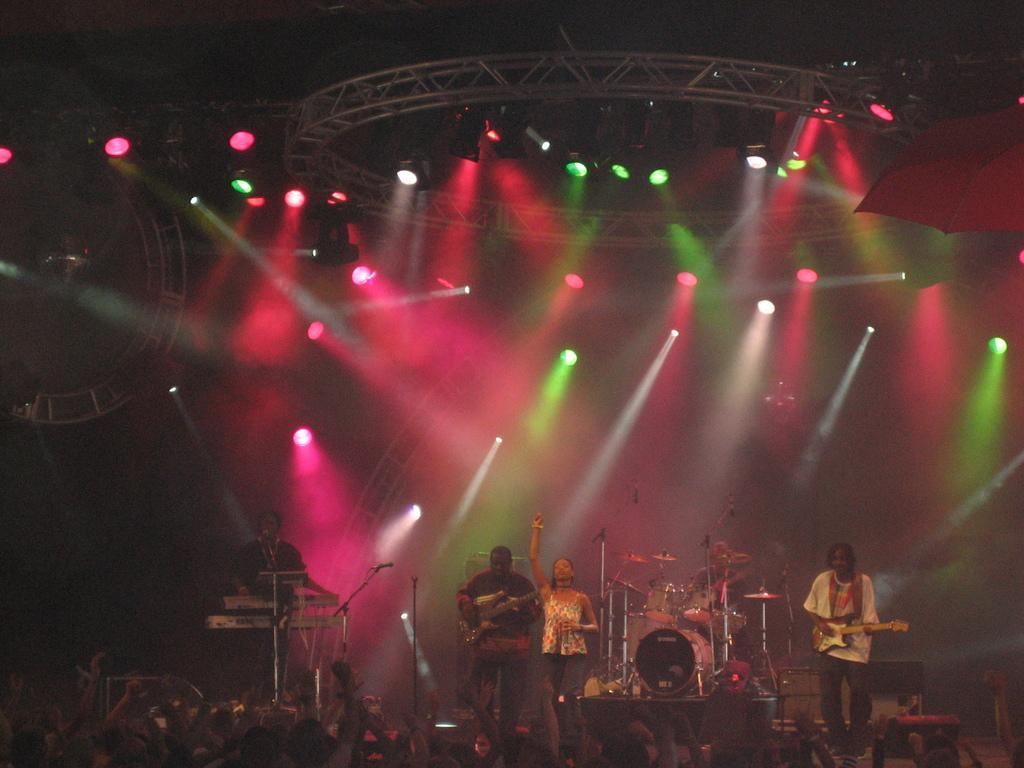Describe this image in one or two sentences. In this image we can see many people are standing near the stage. There are few people playing musical instruments. There are many lights in the image. 